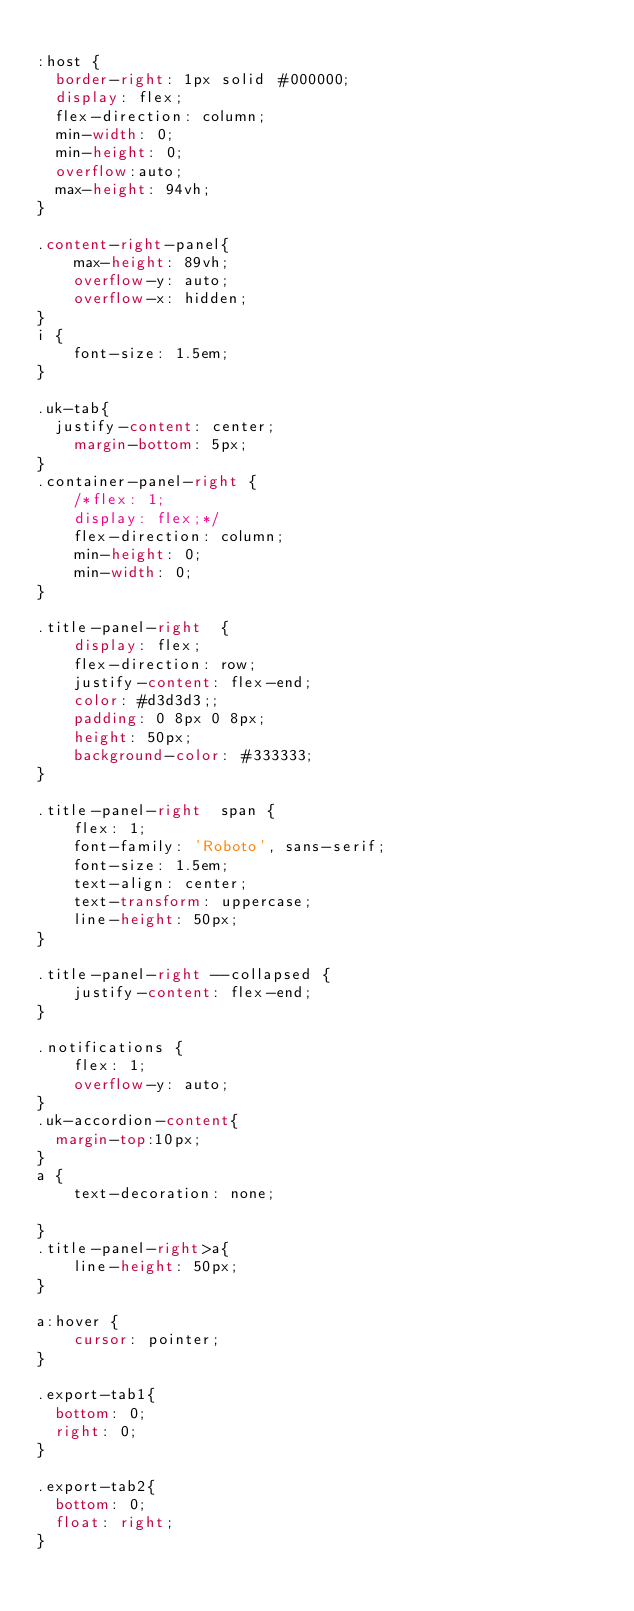Convert code to text. <code><loc_0><loc_0><loc_500><loc_500><_CSS_>
:host {
  border-right: 1px solid #000000;
  display: flex;
  flex-direction: column;
  min-width: 0;
  min-height: 0;
  overflow:auto;
  max-height: 94vh;
}

.content-right-panel{
    max-height: 89vh;
    overflow-y: auto;
    overflow-x: hidden;
}
i {
    font-size: 1.5em;
}

.uk-tab{
  justify-content: center;
    margin-bottom: 5px;
}
.container-panel-right {
    /*flex: 1;
    display: flex;*/
    flex-direction: column;
    min-height: 0;
    min-width: 0;
}

.title-panel-right  {
    display: flex;
    flex-direction: row;
    justify-content: flex-end;
    color: #d3d3d3;;
    padding: 0 8px 0 8px;
    height: 50px;
    background-color: #333333;
}

.title-panel-right  span {
    flex: 1;
    font-family: 'Roboto', sans-serif;
    font-size: 1.5em;
    text-align: center;
    text-transform: uppercase;
    line-height: 50px;
}

.title-panel-right --collapsed {
    justify-content: flex-end;
}

.notifications {
    flex: 1;
    overflow-y: auto;
}
.uk-accordion-content{
  margin-top:10px;
}
a {
    text-decoration: none;

}
.title-panel-right>a{
    line-height: 50px;
}

a:hover {
    cursor: pointer;
}

.export-tab1{
  bottom: 0;
  right: 0;
}

.export-tab2{
  bottom: 0;
  float: right;
}
</code> 